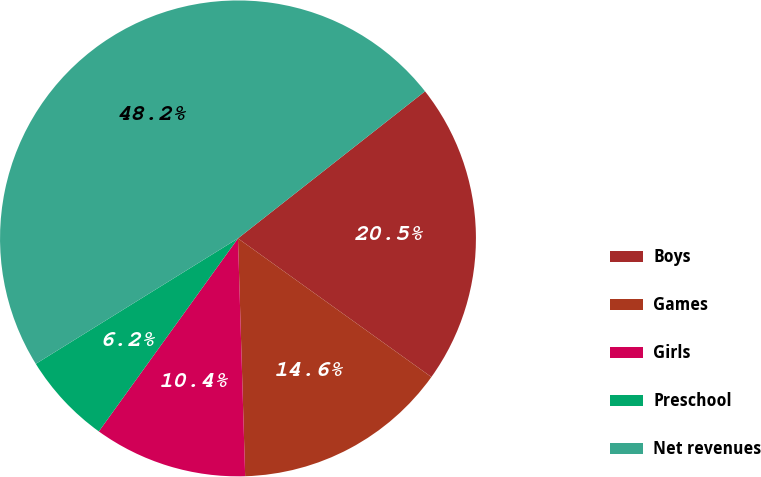Convert chart to OTSL. <chart><loc_0><loc_0><loc_500><loc_500><pie_chart><fcel>Boys<fcel>Games<fcel>Girls<fcel>Preschool<fcel>Net revenues<nl><fcel>20.5%<fcel>14.62%<fcel>10.42%<fcel>6.22%<fcel>48.23%<nl></chart> 